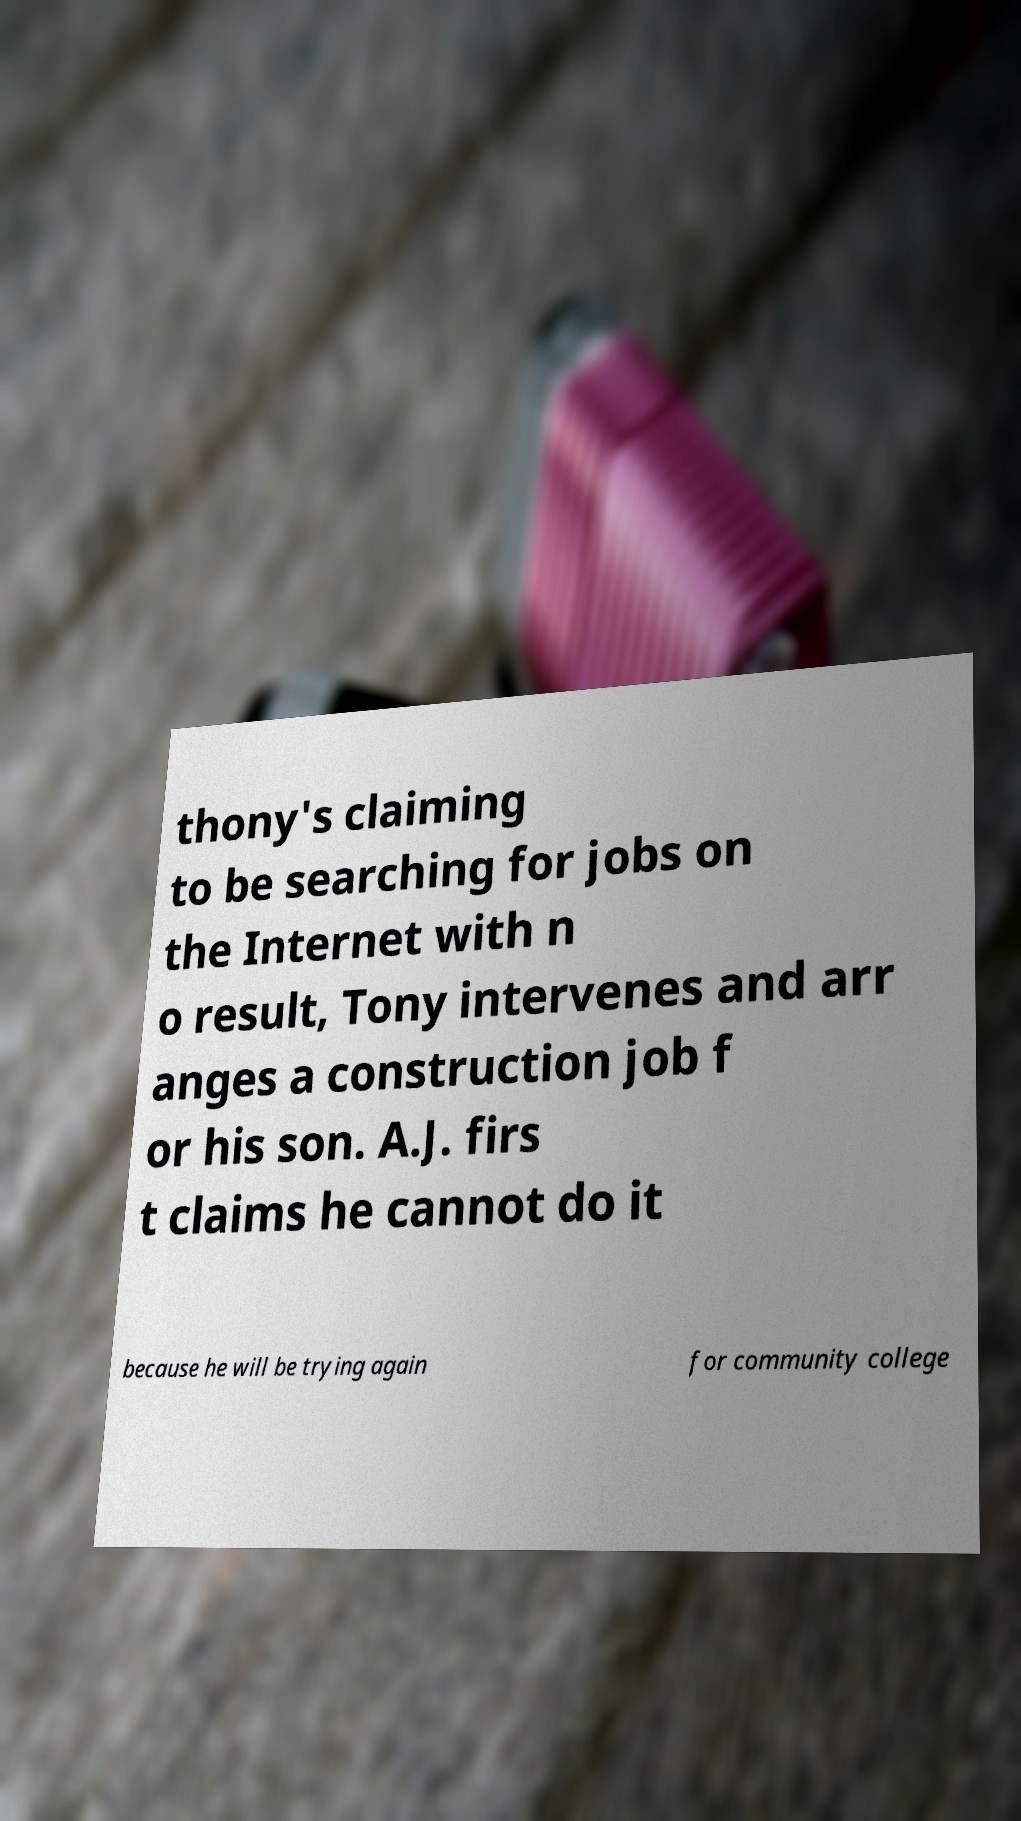Please read and relay the text visible in this image. What does it say? thony's claiming to be searching for jobs on the Internet with n o result, Tony intervenes and arr anges a construction job f or his son. A.J. firs t claims he cannot do it because he will be trying again for community college 